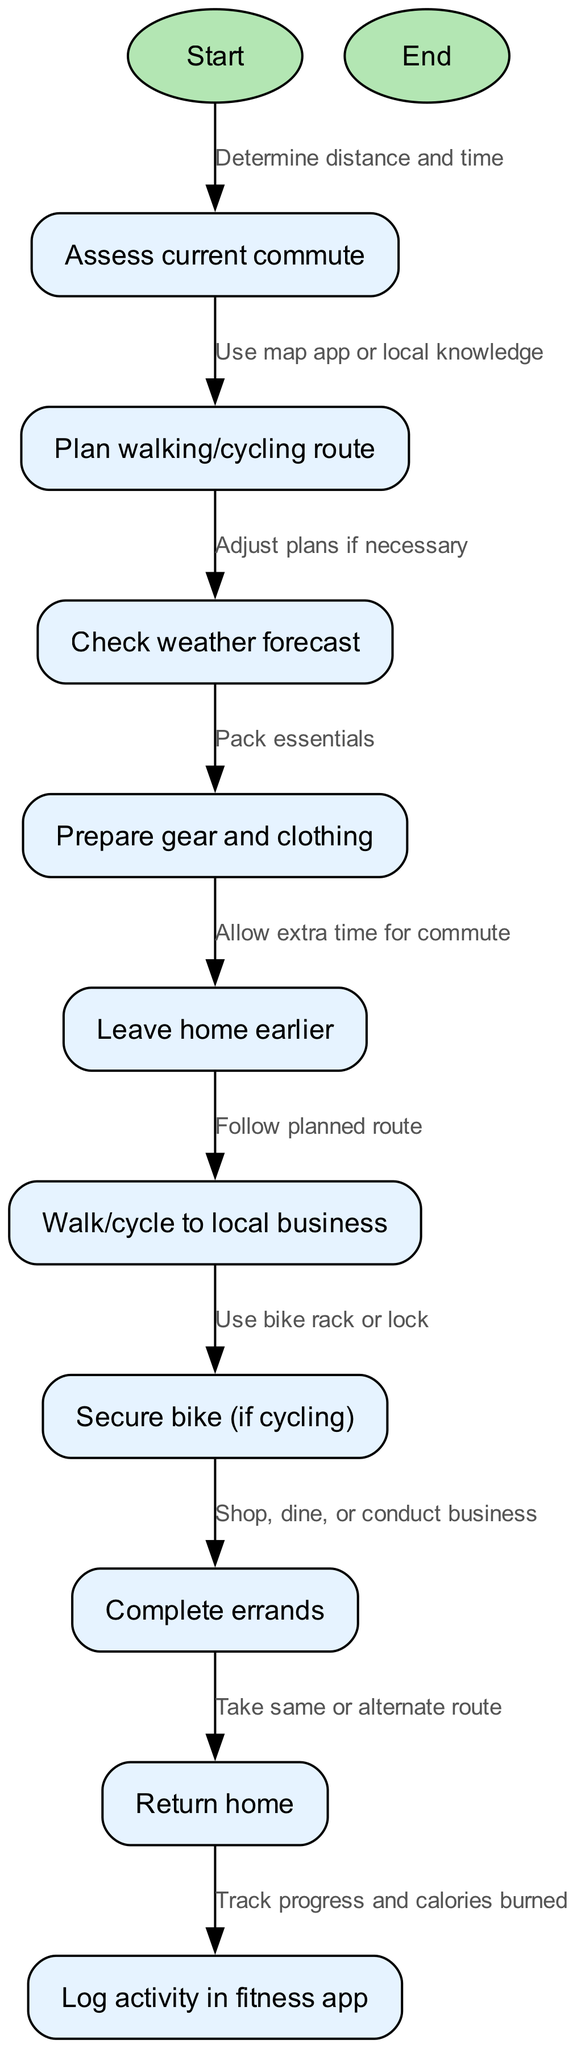What is the first step in the process? The diagram begins with the "Start" node, which is the initial point in the activity flow. Therefore, the first step is simply to start.
Answer: Start How many nodes are there in the diagram? By counting all the distinct nodes listed in the diagram, we find a total of 12 nodes that represent different steps in the process.
Answer: 12 Which node comes after "Check weather forecast"? The node that follows "Check weather forecast" in the diagram is "Prepare gear and clothing," indicating the next action to be taken in the process.
Answer: Prepare gear and clothing What action is required before leaving home? The diagram indicates that one must "Prepare gear and clothing" before proceeding to leave home, making it a necessary step in the process.
Answer: Prepare gear and clothing How do clients secure their bike if they are cycling? The appropriate step illustrated in the diagram for securing a bike is to "Use bike rack or lock," which specifies how to ensure the bike is secured during errands.
Answer: Use bike rack or lock What should clients log after completing their errands? According to the diagram, clients should log their activity in a "fitness app" after completing their errands, capturing exercise details.
Answer: fitness app What is the final step of the process? The end of the process, as depicted in the diagram, is marked by the "End" node, which signifies the completion of the activity.
Answer: End What should clients do if they need to adjust their plans? Clients can "Adjust plans if necessary" after checking the weather forecast, indicating their ability to modify their route based on external conditions.
Answer: Adjust plans if necessary What is one reason for leaving home earlier? The diagram suggests that clients should "Allow extra time for commute," which is a key reason for departing sooner to accommodate potential delays.
Answer: Allow extra time for commute 